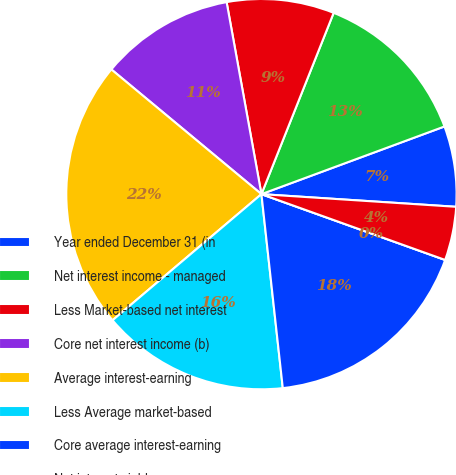Convert chart. <chart><loc_0><loc_0><loc_500><loc_500><pie_chart><fcel>Year ended December 31 (in<fcel>Net interest income - managed<fcel>Less Market-based net interest<fcel>Core net interest income (b)<fcel>Average interest-earning<fcel>Less Average market-based<fcel>Core average interest-earning<fcel>Net interest yield on<fcel>Core net interest yield on<nl><fcel>6.67%<fcel>13.33%<fcel>8.89%<fcel>11.11%<fcel>22.22%<fcel>15.56%<fcel>17.78%<fcel>0.0%<fcel>4.44%<nl></chart> 